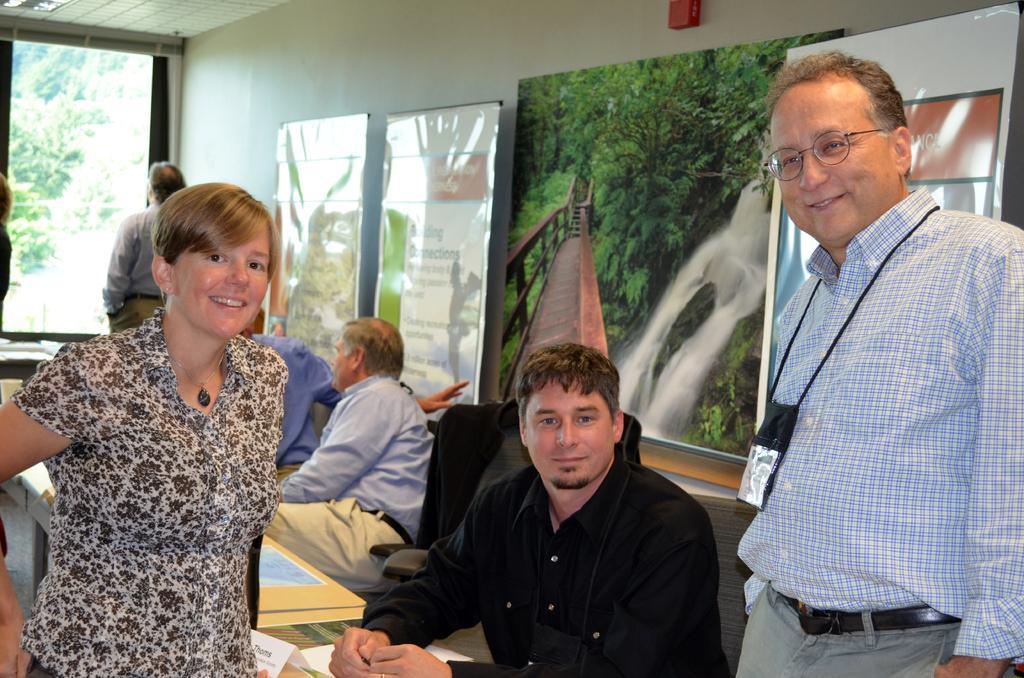Can you describe this image briefly? This image is taken indoors. In the background there is a wall with a few boards and text on them and there is a window. On the right side of the image a man is standing on the floor. On the left side of the image a woman is standing on the floor. In the middle of the image there are four men sitting on the chairs and there is a table. 